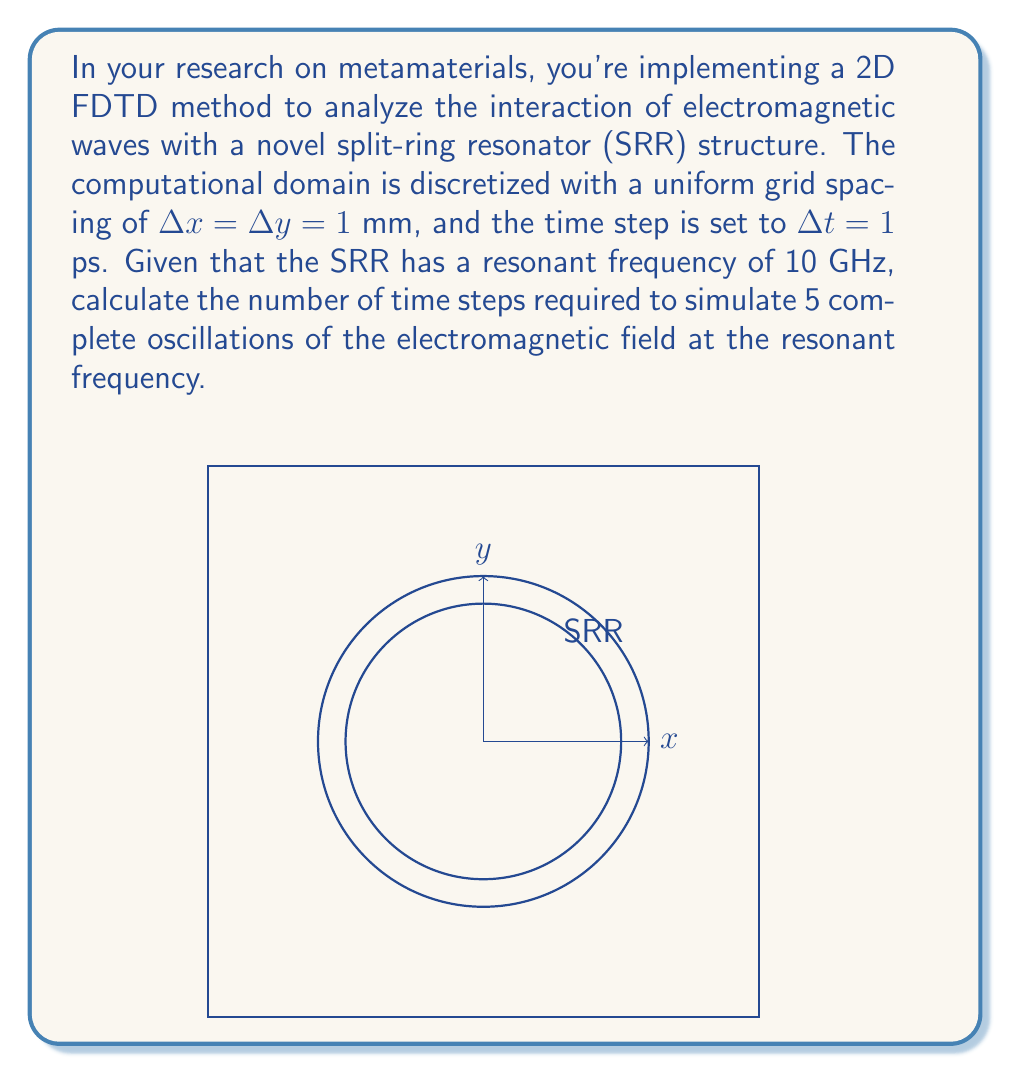Give your solution to this math problem. To solve this problem, we need to follow these steps:

1) First, let's recall the relationship between frequency ($f$), period ($T$), and angular frequency ($\omega$):

   $f = \frac{1}{T}$ and $\omega = 2\pi f$

2) Given the resonant frequency $f = 10$ GHz $= 10 \times 10^9$ Hz, we can calculate the period:

   $T = \frac{1}{f} = \frac{1}{10 \times 10^9} = 100 \times 10^{-12}$ s $= 100$ ps

3) We want to simulate 5 complete oscillations, so the total simulation time ($t_{sim}$) is:

   $t_{sim} = 5T = 5 \times 100$ ps $= 500$ ps

4) Now, we need to determine how many time steps this corresponds to. We know that each time step ($\Delta t$) is 1 ps. The number of time steps ($N$) is given by:

   $N = \frac{t_{sim}}{\Delta t} = \frac{500 \text{ ps}}{1 \text{ ps}} = 500$

Therefore, 500 time steps are required to simulate 5 complete oscillations of the electromagnetic field at the resonant frequency of the SRR.

5) As a note, we should verify that this time step satisfies the Courant-Friedrichs-Lewy (CFL) condition for stability in 2D FDTD:

   $\Delta t \leq \frac{1}{c\sqrt{\frac{1}{(\Delta x)^2} + \frac{1}{(\Delta y)^2}}}$

   Where $c$ is the speed of light. This check is left as an exercise, but it's crucial for ensuring the stability of the FDTD simulation.
Answer: 500 time steps 